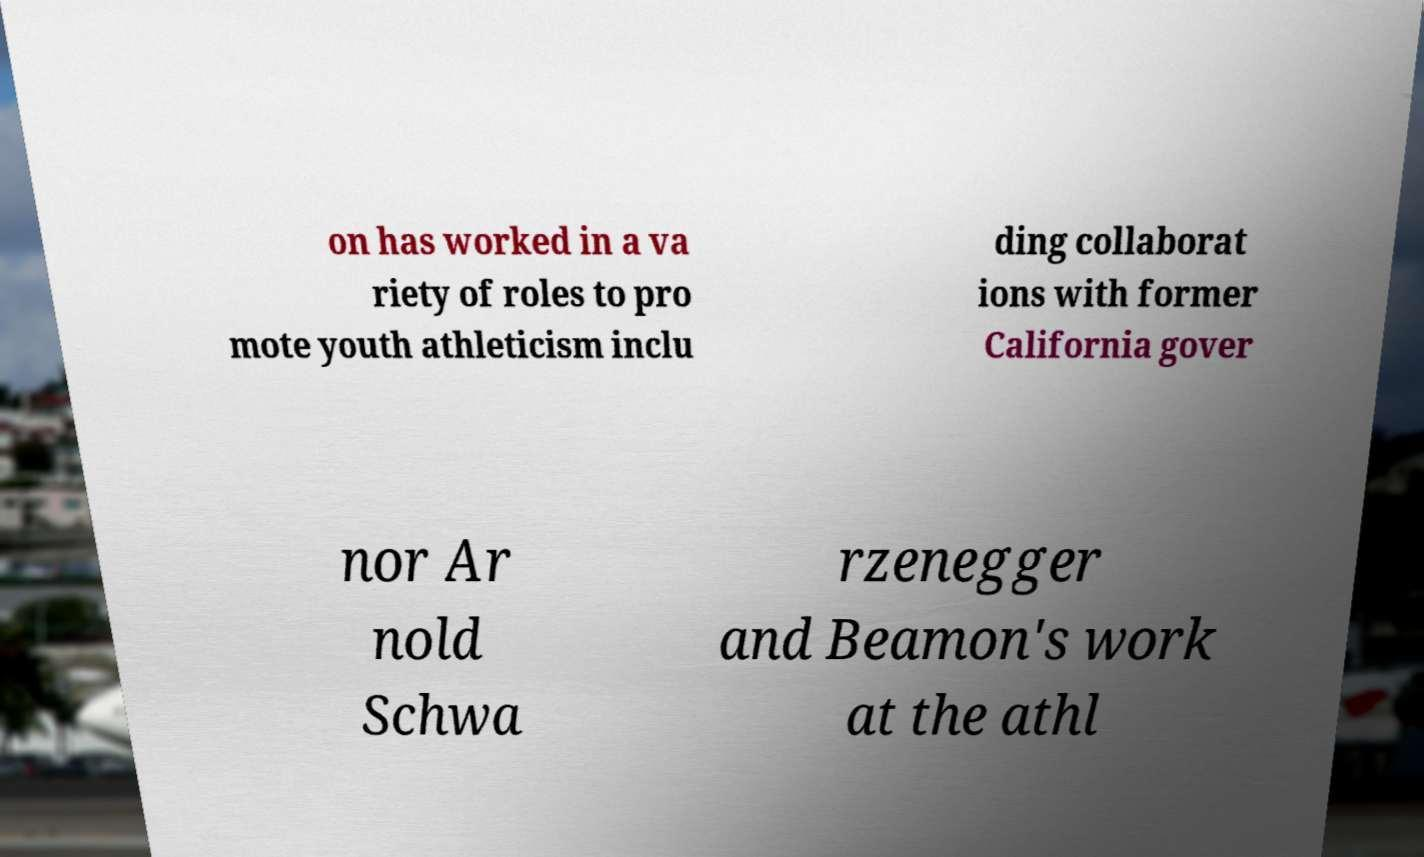Can you read and provide the text displayed in the image?This photo seems to have some interesting text. Can you extract and type it out for me? on has worked in a va riety of roles to pro mote youth athleticism inclu ding collaborat ions with former California gover nor Ar nold Schwa rzenegger and Beamon's work at the athl 